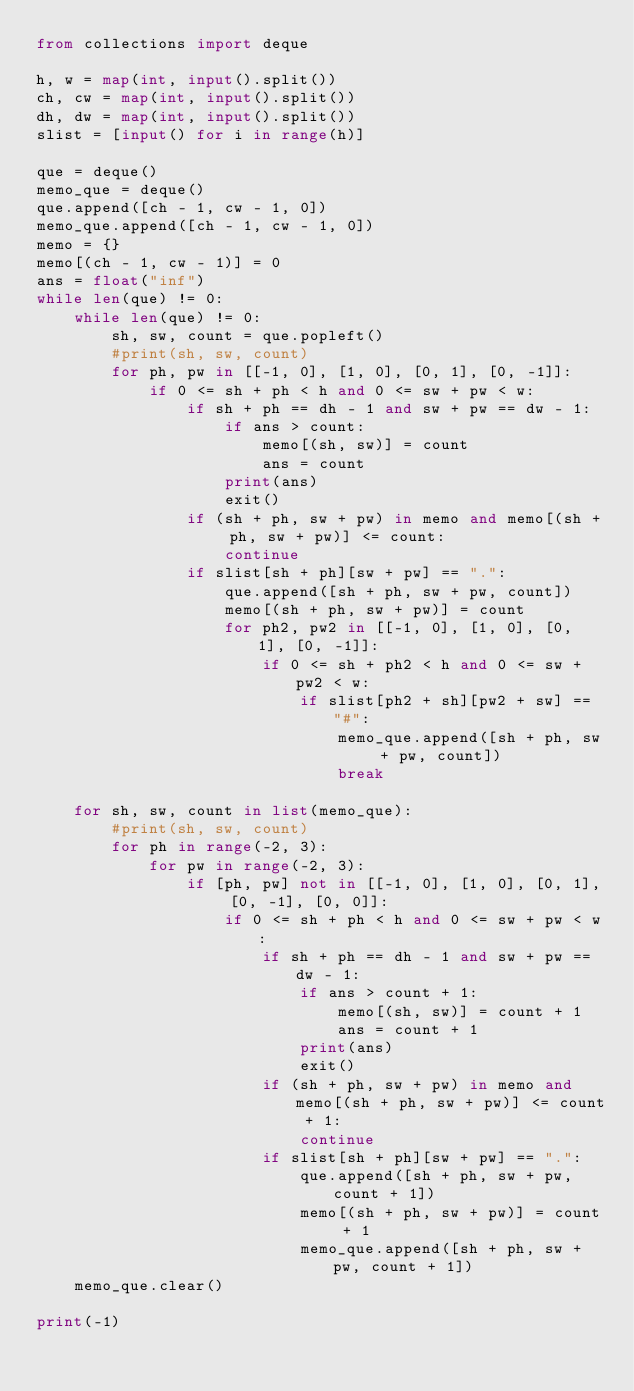<code> <loc_0><loc_0><loc_500><loc_500><_Python_>from collections import deque

h, w = map(int, input().split())
ch, cw = map(int, input().split())
dh, dw = map(int, input().split())
slist = [input() for i in range(h)]

que = deque()
memo_que = deque()
que.append([ch - 1, cw - 1, 0])
memo_que.append([ch - 1, cw - 1, 0])
memo = {}
memo[(ch - 1, cw - 1)] = 0
ans = float("inf")
while len(que) != 0:
    while len(que) != 0:
        sh, sw, count = que.popleft()
        #print(sh, sw, count)
        for ph, pw in [[-1, 0], [1, 0], [0, 1], [0, -1]]:
            if 0 <= sh + ph < h and 0 <= sw + pw < w:
                if sh + ph == dh - 1 and sw + pw == dw - 1:
                    if ans > count:
                        memo[(sh, sw)] = count
                        ans = count
                    print(ans)
                    exit()
                if (sh + ph, sw + pw) in memo and memo[(sh + ph, sw + pw)] <= count:
                    continue
                if slist[sh + ph][sw + pw] == ".":
                    que.append([sh + ph, sw + pw, count])
                    memo[(sh + ph, sw + pw)] = count
                    for ph2, pw2 in [[-1, 0], [1, 0], [0, 1], [0, -1]]:
                        if 0 <= sh + ph2 < h and 0 <= sw + pw2 < w:
                            if slist[ph2 + sh][pw2 + sw] == "#":
                                memo_que.append([sh + ph, sw + pw, count])
                                break

    for sh, sw, count in list(memo_que):
        #print(sh, sw, count)
        for ph in range(-2, 3):
            for pw in range(-2, 3):
                if [ph, pw] not in [[-1, 0], [1, 0], [0, 1], [0, -1], [0, 0]]:
                    if 0 <= sh + ph < h and 0 <= sw + pw < w:
                        if sh + ph == dh - 1 and sw + pw == dw - 1:
                            if ans > count + 1:
                                memo[(sh, sw)] = count + 1
                                ans = count + 1
                            print(ans)
                            exit()
                        if (sh + ph, sw + pw) in memo and memo[(sh + ph, sw + pw)] <= count + 1:
                            continue
                        if slist[sh + ph][sw + pw] == ".":
                            que.append([sh + ph, sw + pw, count + 1])
                            memo[(sh + ph, sw + pw)] = count + 1
                            memo_que.append([sh + ph, sw + pw, count + 1])
    memo_que.clear()

print(-1)</code> 